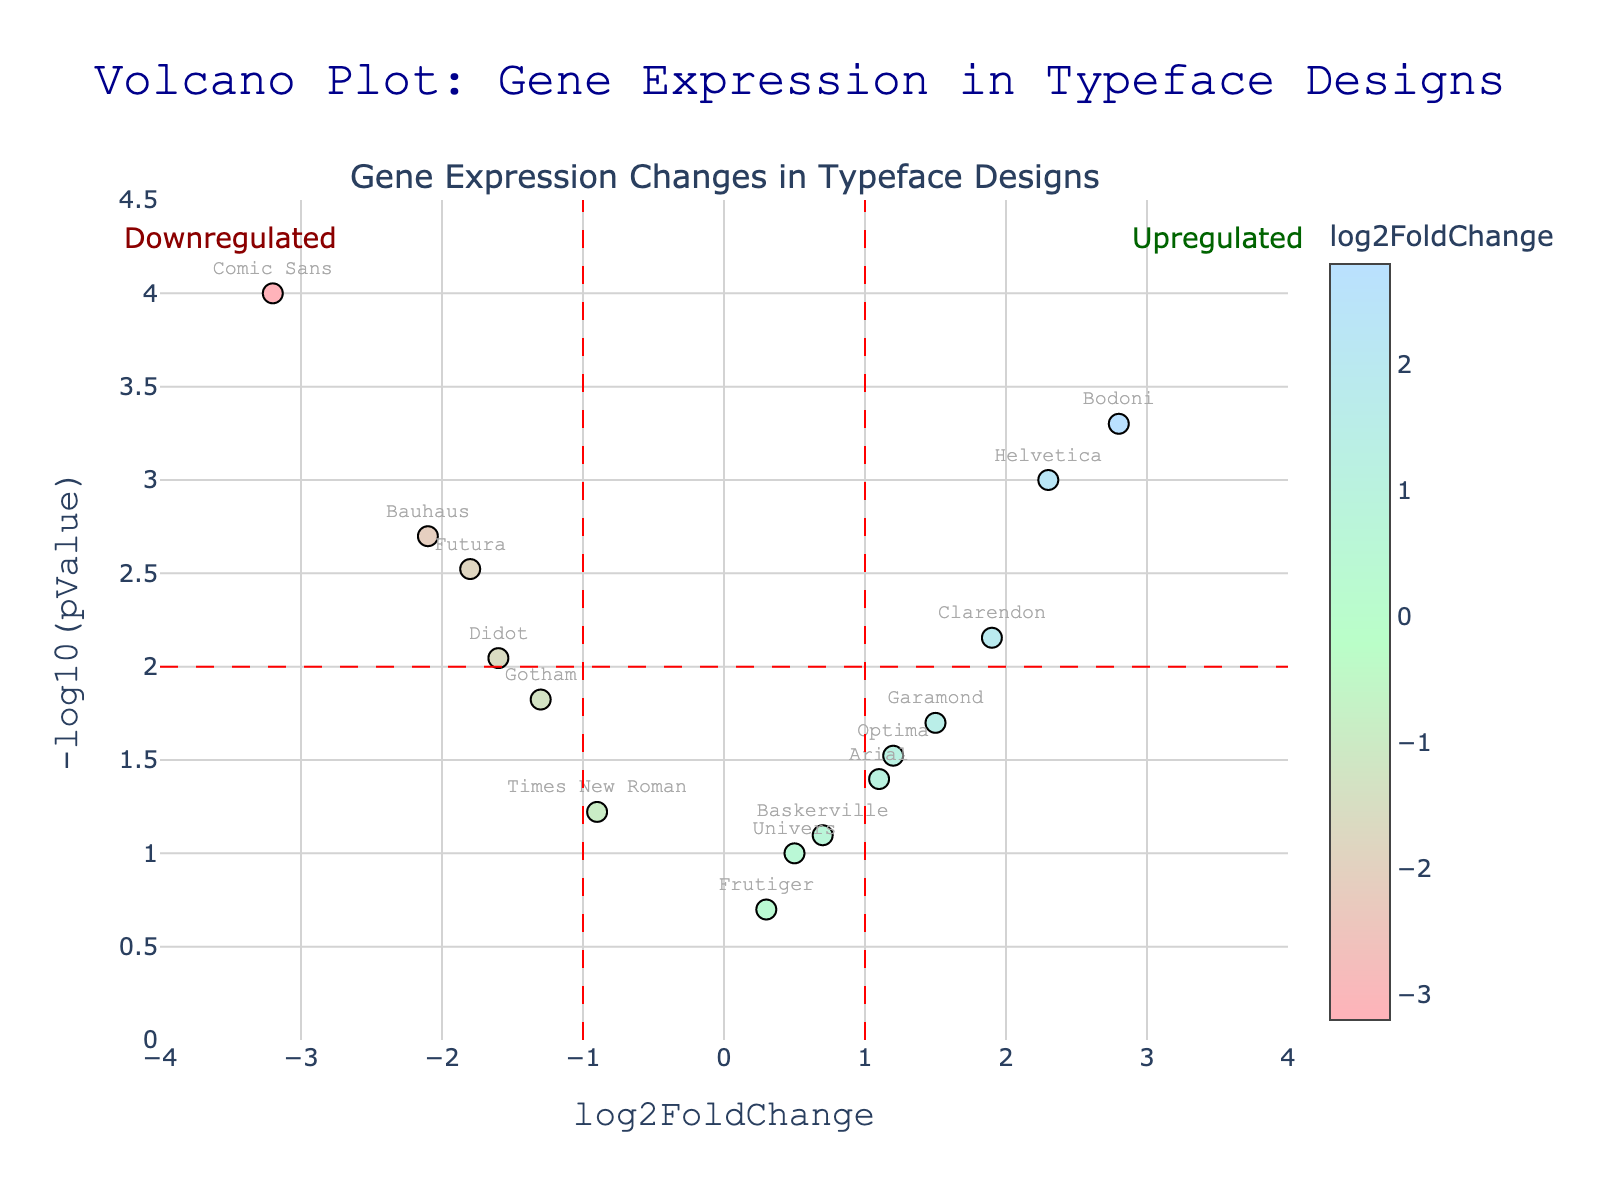What's the title of the plot? The plot's title is prominently displayed at the top center of the figure.
Answer: Volcano Plot: Gene Expression in Typeface Designs How many typeface designs are significantly upregulated? Significant upregulation is indicated by typeface designs with a log2FoldChange greater than 1 and -log10(pValue) greater than 2, which are marked in the top-right section. Helvetica, Bodoni, and Clarendon fulfill these criteria.
Answer: 3 Which typeface design is the most downregulated and significant? The most downregulated typeface design would have the lowest log2FoldChange alongside a high -log10(pValue). Checking the lower-left section, Comic Sans fits this description with a log2FoldChange of -3.2 and a -log10(pValue) of 4.
Answer: Comic Sans Are there any typeface designs that are neither significantly upregulated nor downregulated? Typefaces that fall between log2FoldChange of -1 and 1 and have a -log10(pValue) below 2 are not significantly regulated. Baskerville, Times New Roman, Univers, Frutiger, and Optima meet these criteria.
Answer: 5 Which typeface design has the highest log2FoldChange? The typeface design with the highest log2FoldChange, based on the figure's x-axis values, is Bodoni with a log2FoldChange of 2.8.
Answer: Bodoni What is the pValue threshold for significance marked on the plot? The significance threshold is visually indicated by a horizontal line at -log10(pValue) = 2. This corresponds to a pValue of 0.01 (since -log10(0.01) = 2).
Answer: 0.01 Which typeface design has both a positive log2FoldChange and a pValue above the significance threshold but is not the highest in either measure? Garamond meets the criteria with a log2FoldChange of 1.5 and a -log10(pValue) just above 1.7, showing it is positive and above the threshold but neither the highest in log2FoldChange nor -log10(pValue).
Answer: Garamond Of the typefaces listed, how many show significant downregulation? Significant downregulation is observed in typefaces with a log2FoldChange less than -1 and a -log10(pValue) greater than 2. Only Comic Sans and Bauhaus meet these criteria.
Answer: 2 What's the range of -log10(pValue) on the y-axis? The y-axis range is obvious from the gridlines and starts at 0 and goes up to approximately 4.5 as outlined in the plot layout.
Answer: 0 to 4.5 